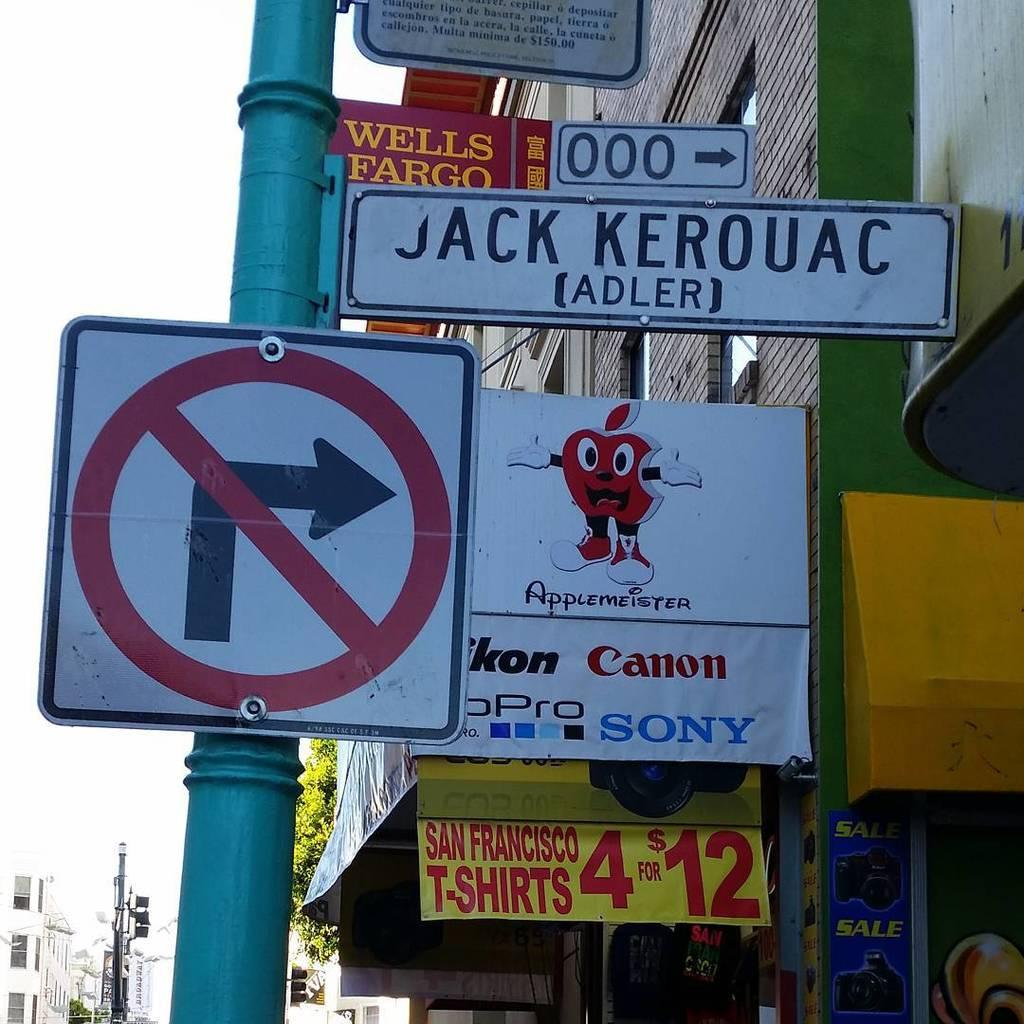<image>
Give a short and clear explanation of the subsequent image. A sign advertises brands such as Sony and Canon. 